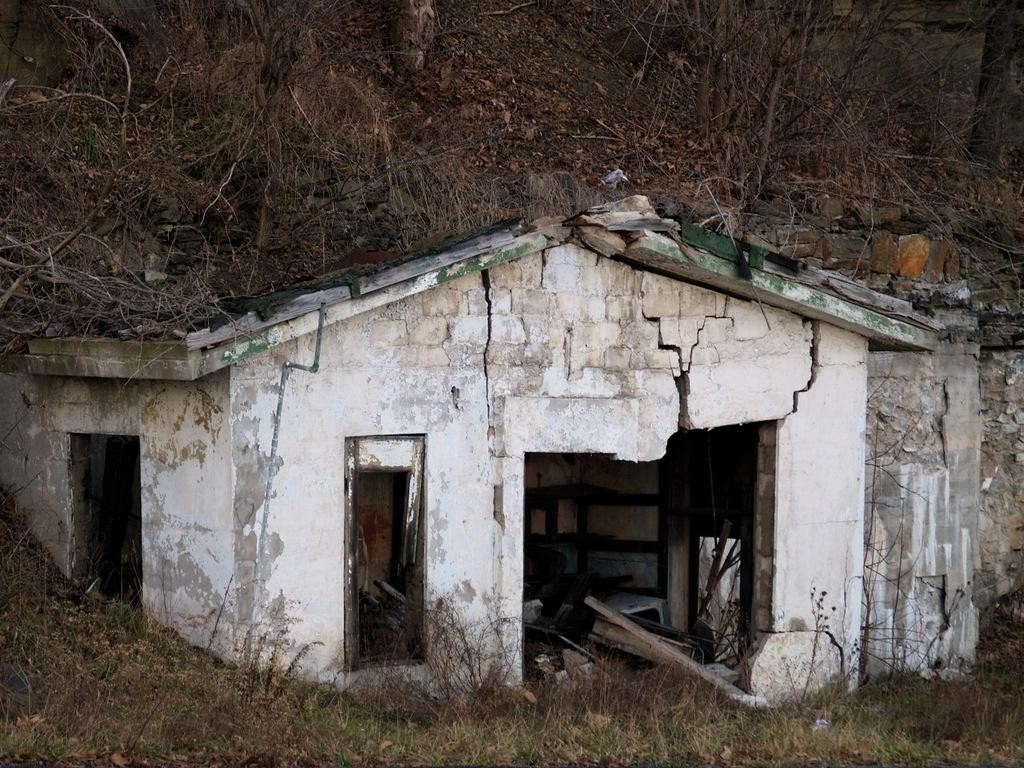What type of structure is visible in the image? There is a house in the image. Can you describe the interior of the house? The facts provided do not give specific details about the interior of the house, but we know that there are objects inside the house. What can be seen in the background of the image? There are trees and grass in the background of the image. What type of quartz can be seen on the cake in the image? There is no cake or quartz present in the image. 